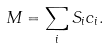<formula> <loc_0><loc_0><loc_500><loc_500>M = \sum _ { i } S _ { i } c _ { i } .</formula> 